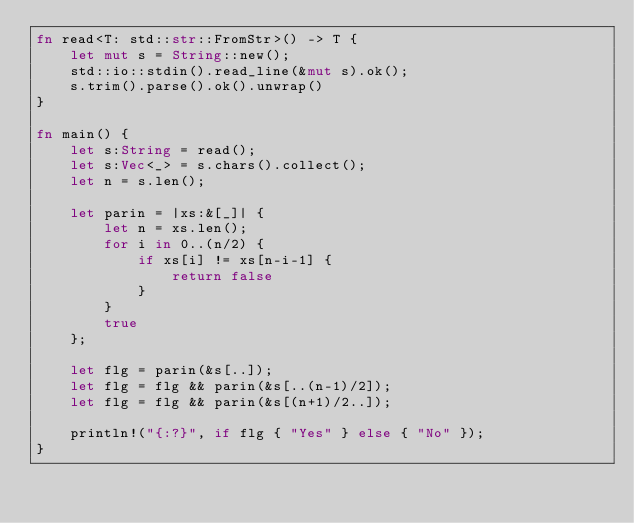<code> <loc_0><loc_0><loc_500><loc_500><_Rust_>fn read<T: std::str::FromStr>() -> T {
    let mut s = String::new();
    std::io::stdin().read_line(&mut s).ok();
    s.trim().parse().ok().unwrap()
}

fn main() {
    let s:String = read();
    let s:Vec<_> = s.chars().collect();
    let n = s.len();

    let parin = |xs:&[_]| {
        let n = xs.len();
        for i in 0..(n/2) {
            if xs[i] != xs[n-i-1] {
                return false
            }
        }
        true
    };

    let flg = parin(&s[..]);
    let flg = flg && parin(&s[..(n-1)/2]);
    let flg = flg && parin(&s[(n+1)/2..]);

    println!("{:?}", if flg { "Yes" } else { "No" });
}
</code> 